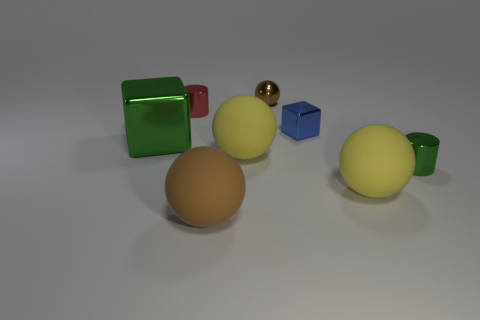What material is the other brown thing that is the same shape as the tiny brown metal object?
Give a very brief answer. Rubber. What size is the brown thing that is behind the cylinder left of the big rubber ball that is right of the tiny blue shiny thing?
Keep it short and to the point. Small. There is a red cylinder; are there any objects in front of it?
Your answer should be compact. Yes. What size is the other green thing that is made of the same material as the small green thing?
Your response must be concise. Large. How many small red objects have the same shape as the brown metallic thing?
Keep it short and to the point. 0. Is the material of the small brown object the same as the small cylinder behind the big block?
Keep it short and to the point. Yes. Is the number of yellow rubber spheres right of the big brown matte thing greater than the number of tiny blue metal things?
Offer a very short reply. Yes. What is the shape of the matte object that is the same color as the small ball?
Keep it short and to the point. Sphere. Is there a large red object that has the same material as the small brown object?
Give a very brief answer. No. Are the cube to the left of the small blue metallic block and the tiny cylinder to the right of the small brown metal object made of the same material?
Ensure brevity in your answer.  Yes. 